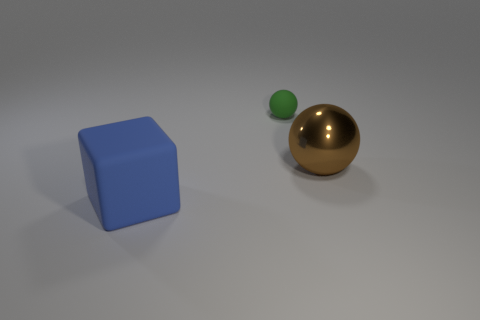Add 2 big blue objects. How many objects exist? 5 Subtract all blocks. How many objects are left? 2 Add 2 tiny brown spheres. How many tiny brown spheres exist? 2 Subtract 0 red cylinders. How many objects are left? 3 Subtract all green balls. Subtract all big rubber blocks. How many objects are left? 1 Add 2 shiny balls. How many shiny balls are left? 3 